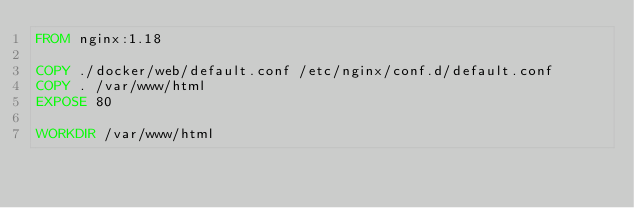<code> <loc_0><loc_0><loc_500><loc_500><_Dockerfile_>FROM nginx:1.18

COPY ./docker/web/default.conf /etc/nginx/conf.d/default.conf
COPY . /var/www/html
EXPOSE 80

WORKDIR /var/www/html</code> 